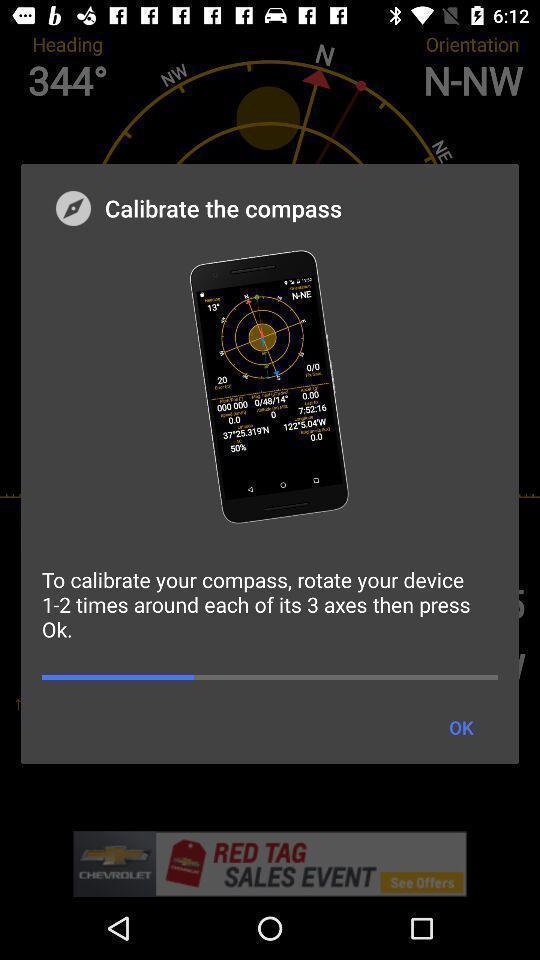Describe the visual elements of this screenshot. Pop-up displaying details of compass. 